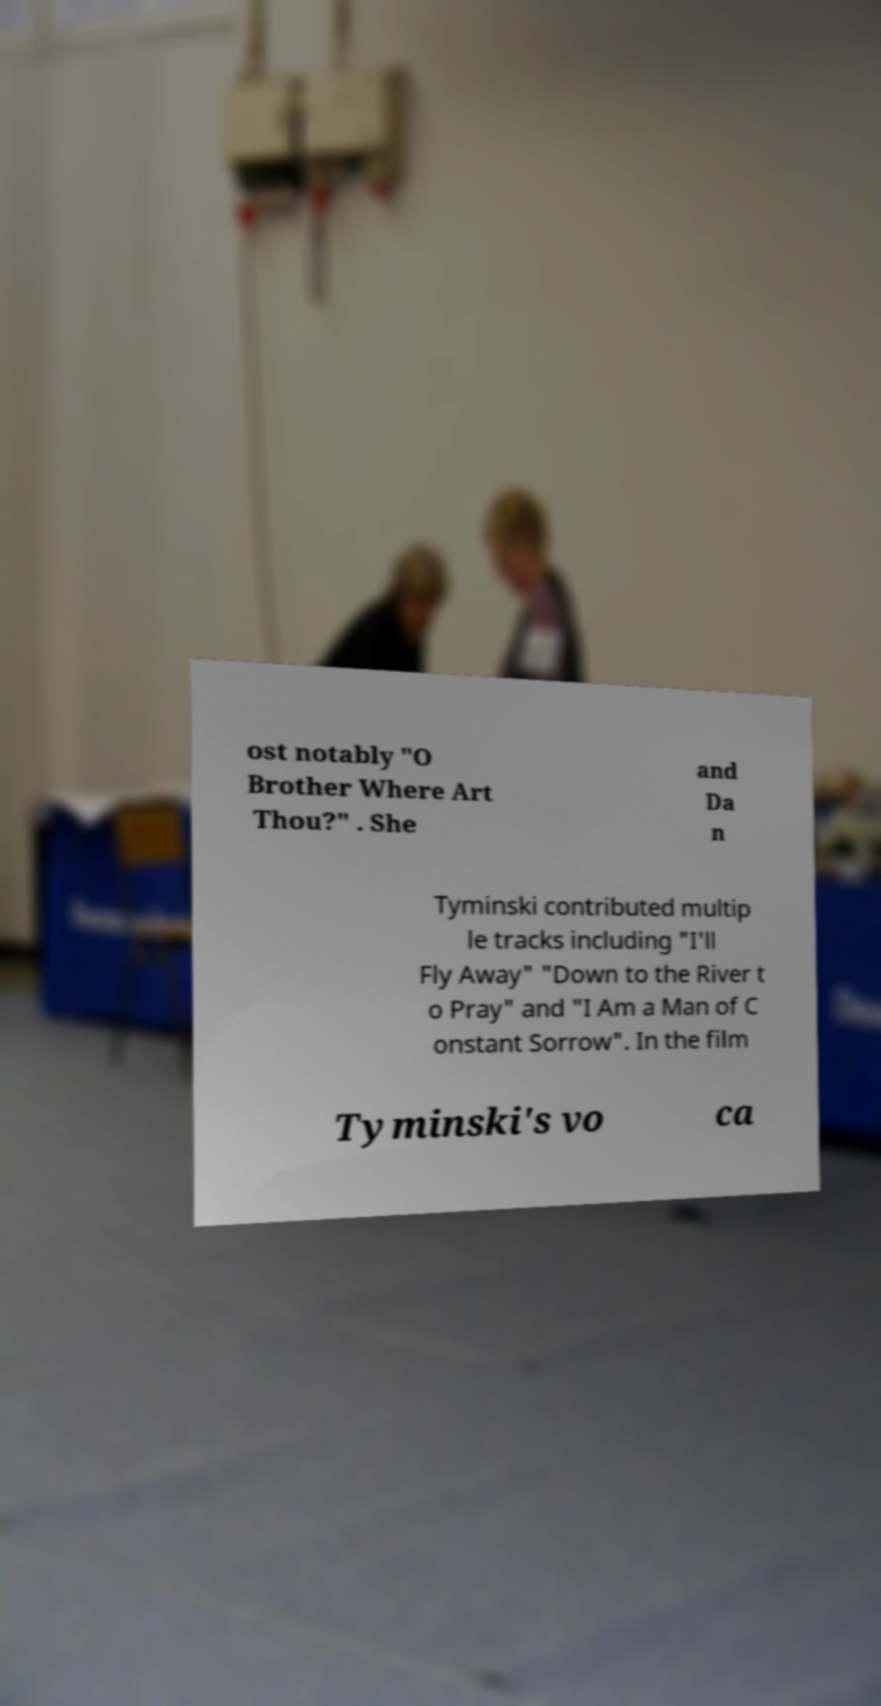I need the written content from this picture converted into text. Can you do that? ost notably "O Brother Where Art Thou?" . She and Da n Tyminski contributed multip le tracks including "I'll Fly Away" "Down to the River t o Pray" and "I Am a Man of C onstant Sorrow". In the film Tyminski's vo ca 